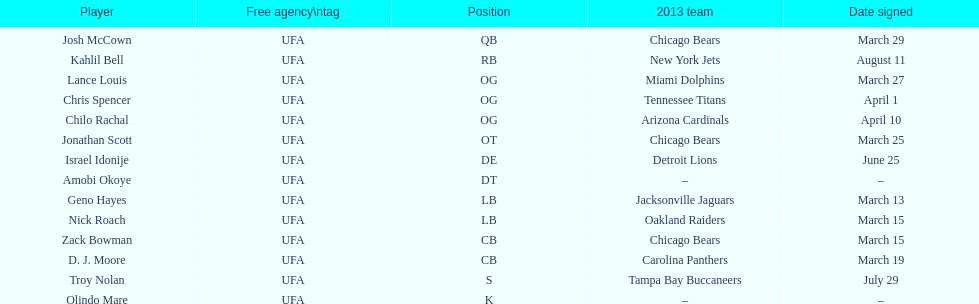Help me parse the entirety of this table. {'header': ['Player', 'Free agency\\ntag', 'Position', '2013 team', 'Date signed'], 'rows': [['Josh McCown', 'UFA', 'QB', 'Chicago Bears', 'March 29'], ['Kahlil Bell', 'UFA', 'RB', 'New York Jets', 'August 11'], ['Lance Louis', 'UFA', 'OG', 'Miami Dolphins', 'March 27'], ['Chris Spencer', 'UFA', 'OG', 'Tennessee Titans', 'April 1'], ['Chilo Rachal', 'UFA', 'OG', 'Arizona Cardinals', 'April 10'], ['Jonathan Scott', 'UFA', 'OT', 'Chicago Bears', 'March 25'], ['Israel Idonije', 'UFA', 'DE', 'Detroit Lions', 'June 25'], ['Amobi Okoye', 'UFA', 'DT', '–', '–'], ['Geno Hayes', 'UFA', 'LB', 'Jacksonville Jaguars', 'March 13'], ['Nick Roach', 'UFA', 'LB', 'Oakland Raiders', 'March 15'], ['Zack Bowman', 'UFA', 'CB', 'Chicago Bears', 'March 15'], ['D. J. Moore', 'UFA', 'CB', 'Carolina Panthers', 'March 19'], ['Troy Nolan', 'UFA', 'S', 'Tampa Bay Buccaneers', 'July 29'], ['Olindo Mare', 'UFA', 'K', '–', '–']]} Nick roach was signed on the same day as which other player? Zack Bowman. 